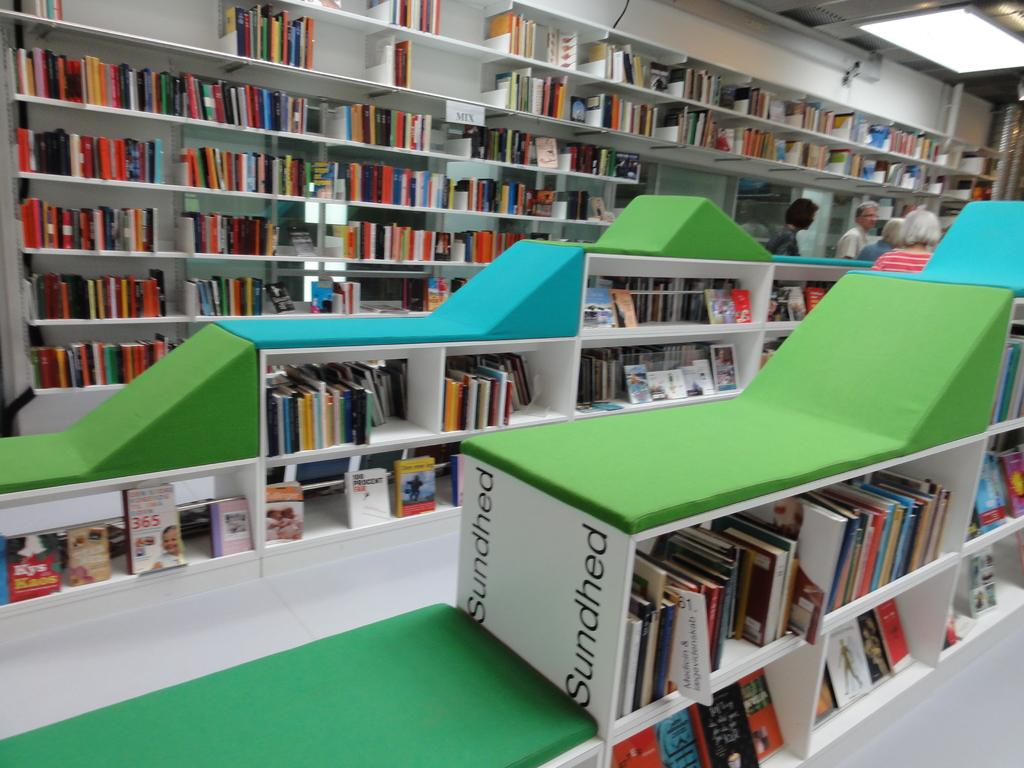<image>
Render a clear and concise summary of the photo. A room with filled with books on white bookshelves labelled Sundhead 